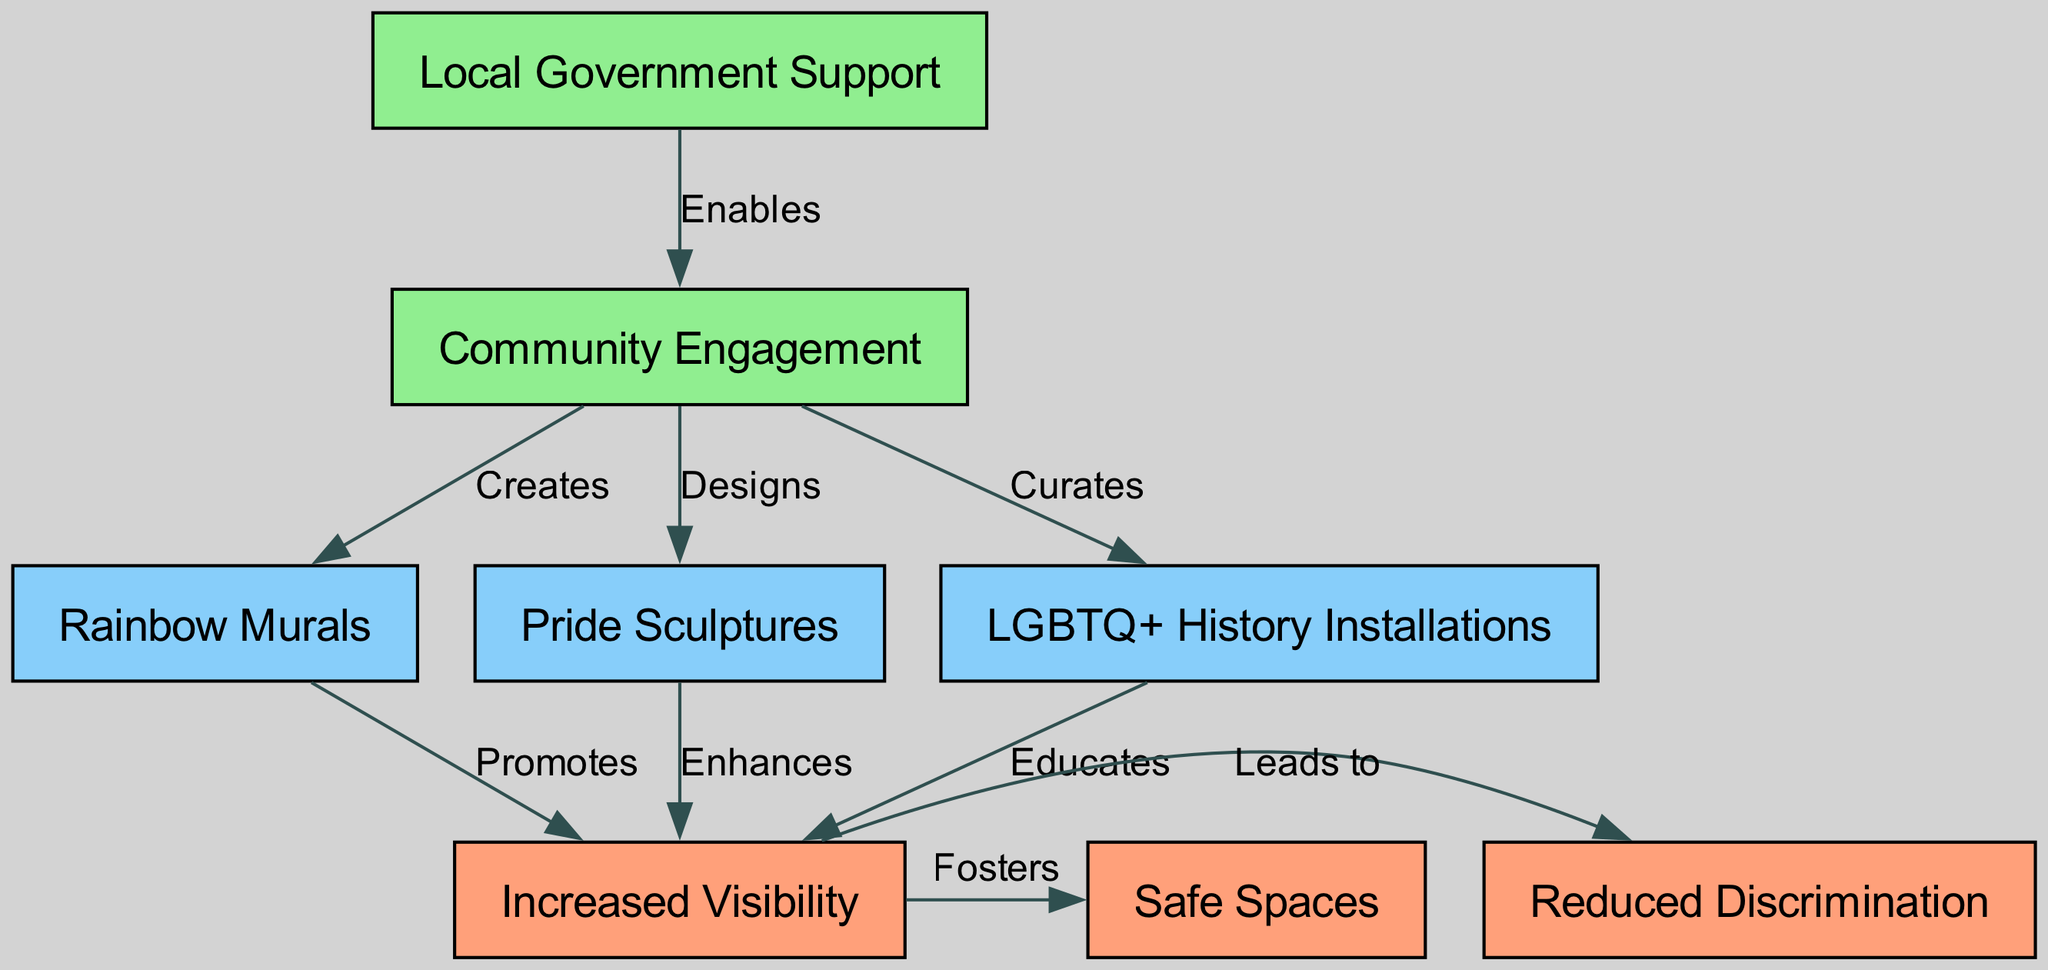What are the three types of public art installations listed in the diagram? The diagram lists three types of public art installations: Rainbow Murals, Pride Sculptures, and LGBTQ+ History Installations.
Answer: Rainbow Murals, Pride Sculptures, LGBTQ+ History Installations How many connections are there between the public art installations and increased visibility? There are three edges connecting the public art installations (Rainbow Murals, Pride Sculptures, LGBTQ+ History Installations) to Increased Visibility. Each installation promotes or enhances this visibility.
Answer: 3 What role does community engagement play in relation to the public art installations? Community Engagement creates, designs, and curates the public art installations, which are essential for the art's presence and development in urban spaces.
Answer: Creates, designs, curates What is the relationship between increased visibility and reduced discrimination? Increased Visibility leads to Reduced Discrimination, indicating that as visibility increases, discrimination decreases, thus highlighting the impact of public art on societal perceptions.
Answer: Leads to Which node does local government support enable? Local Government Support enables Community Engagement, suggesting that government backing is crucial for fostering community involvement in public art.
Answer: Community Engagement How does the diagram depict the effect of public art on the creation of safe spaces? The diagram shows that Increased Visibility fosters Safe Spaces, illustrating that by enhancing visibility, the public art contributes to the establishment of environments where LGBTQ+ individuals feel safe.
Answer: Fosters What color represents the public art installations in the diagram? The public art installations (Rainbow Murals, Pride Sculptures, LGBTQ+ History Installations) are represented by the color lightskyblue in the diagram.
Answer: Lightskyblue Which factor contributes to both increased visibility and the reduction of discrimination? Increased Visibility contributes to Reduced Discrimination, showing a direct impact of visibility on improving societal attitudes against discrimination within urban spaces.
Answer: Increased Visibility What is the main outcome of local government support according to the diagram? The main outcome of Local Government Support is enabling Community Engagement, which underlines the importance of governmental involvement in promoting public art.
Answer: Enables Community Engagement 